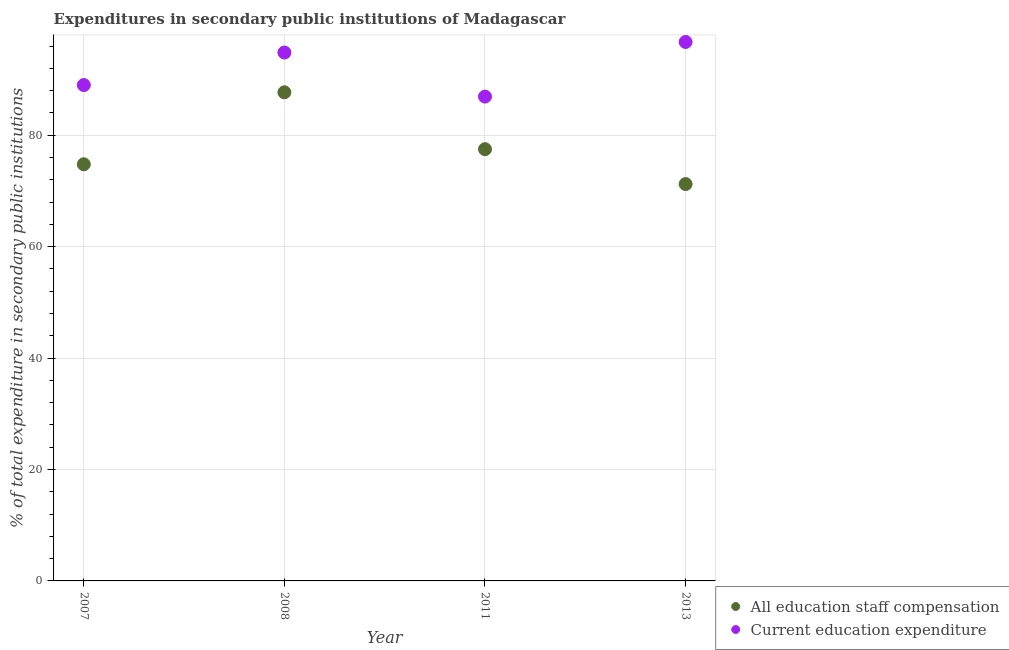How many different coloured dotlines are there?
Your answer should be very brief. 2. What is the expenditure in staff compensation in 2013?
Ensure brevity in your answer.  71.24. Across all years, what is the maximum expenditure in staff compensation?
Your response must be concise. 87.71. Across all years, what is the minimum expenditure in staff compensation?
Your response must be concise. 71.24. What is the total expenditure in staff compensation in the graph?
Offer a very short reply. 311.25. What is the difference between the expenditure in education in 2008 and that in 2013?
Your answer should be compact. -1.89. What is the difference between the expenditure in staff compensation in 2011 and the expenditure in education in 2007?
Your response must be concise. -11.51. What is the average expenditure in staff compensation per year?
Give a very brief answer. 77.81. In the year 2007, what is the difference between the expenditure in education and expenditure in staff compensation?
Your answer should be very brief. 14.22. In how many years, is the expenditure in staff compensation greater than 84 %?
Offer a very short reply. 1. What is the ratio of the expenditure in staff compensation in 2008 to that in 2011?
Offer a very short reply. 1.13. What is the difference between the highest and the second highest expenditure in education?
Your response must be concise. 1.89. What is the difference between the highest and the lowest expenditure in education?
Give a very brief answer. 9.8. Is the sum of the expenditure in education in 2011 and 2013 greater than the maximum expenditure in staff compensation across all years?
Your response must be concise. Yes. Is the expenditure in staff compensation strictly less than the expenditure in education over the years?
Your response must be concise. Yes. How many dotlines are there?
Your response must be concise. 2. Are the values on the major ticks of Y-axis written in scientific E-notation?
Make the answer very short. No. Where does the legend appear in the graph?
Your answer should be very brief. Bottom right. How many legend labels are there?
Your answer should be very brief. 2. What is the title of the graph?
Provide a short and direct response. Expenditures in secondary public institutions of Madagascar. What is the label or title of the X-axis?
Offer a terse response. Year. What is the label or title of the Y-axis?
Your answer should be very brief. % of total expenditure in secondary public institutions. What is the % of total expenditure in secondary public institutions in All education staff compensation in 2007?
Provide a short and direct response. 74.79. What is the % of total expenditure in secondary public institutions in Current education expenditure in 2007?
Provide a succinct answer. 89.01. What is the % of total expenditure in secondary public institutions in All education staff compensation in 2008?
Provide a short and direct response. 87.71. What is the % of total expenditure in secondary public institutions in Current education expenditure in 2008?
Your response must be concise. 94.86. What is the % of total expenditure in secondary public institutions of All education staff compensation in 2011?
Keep it short and to the point. 77.5. What is the % of total expenditure in secondary public institutions of Current education expenditure in 2011?
Make the answer very short. 86.95. What is the % of total expenditure in secondary public institutions in All education staff compensation in 2013?
Your response must be concise. 71.24. What is the % of total expenditure in secondary public institutions of Current education expenditure in 2013?
Give a very brief answer. 96.75. Across all years, what is the maximum % of total expenditure in secondary public institutions of All education staff compensation?
Ensure brevity in your answer.  87.71. Across all years, what is the maximum % of total expenditure in secondary public institutions in Current education expenditure?
Offer a terse response. 96.75. Across all years, what is the minimum % of total expenditure in secondary public institutions of All education staff compensation?
Make the answer very short. 71.24. Across all years, what is the minimum % of total expenditure in secondary public institutions of Current education expenditure?
Give a very brief answer. 86.95. What is the total % of total expenditure in secondary public institutions of All education staff compensation in the graph?
Your answer should be compact. 311.25. What is the total % of total expenditure in secondary public institutions in Current education expenditure in the graph?
Provide a short and direct response. 367.56. What is the difference between the % of total expenditure in secondary public institutions of All education staff compensation in 2007 and that in 2008?
Your answer should be compact. -12.92. What is the difference between the % of total expenditure in secondary public institutions of Current education expenditure in 2007 and that in 2008?
Provide a succinct answer. -5.84. What is the difference between the % of total expenditure in secondary public institutions of All education staff compensation in 2007 and that in 2011?
Your response must be concise. -2.71. What is the difference between the % of total expenditure in secondary public institutions of Current education expenditure in 2007 and that in 2011?
Make the answer very short. 2.07. What is the difference between the % of total expenditure in secondary public institutions of All education staff compensation in 2007 and that in 2013?
Give a very brief answer. 3.55. What is the difference between the % of total expenditure in secondary public institutions of Current education expenditure in 2007 and that in 2013?
Offer a terse response. -7.73. What is the difference between the % of total expenditure in secondary public institutions in All education staff compensation in 2008 and that in 2011?
Your response must be concise. 10.21. What is the difference between the % of total expenditure in secondary public institutions in Current education expenditure in 2008 and that in 2011?
Keep it short and to the point. 7.91. What is the difference between the % of total expenditure in secondary public institutions of All education staff compensation in 2008 and that in 2013?
Your answer should be very brief. 16.47. What is the difference between the % of total expenditure in secondary public institutions in Current education expenditure in 2008 and that in 2013?
Offer a very short reply. -1.89. What is the difference between the % of total expenditure in secondary public institutions of All education staff compensation in 2011 and that in 2013?
Your answer should be compact. 6.26. What is the difference between the % of total expenditure in secondary public institutions of Current education expenditure in 2011 and that in 2013?
Your answer should be compact. -9.8. What is the difference between the % of total expenditure in secondary public institutions in All education staff compensation in 2007 and the % of total expenditure in secondary public institutions in Current education expenditure in 2008?
Ensure brevity in your answer.  -20.06. What is the difference between the % of total expenditure in secondary public institutions in All education staff compensation in 2007 and the % of total expenditure in secondary public institutions in Current education expenditure in 2011?
Offer a very short reply. -12.15. What is the difference between the % of total expenditure in secondary public institutions of All education staff compensation in 2007 and the % of total expenditure in secondary public institutions of Current education expenditure in 2013?
Ensure brevity in your answer.  -21.96. What is the difference between the % of total expenditure in secondary public institutions in All education staff compensation in 2008 and the % of total expenditure in secondary public institutions in Current education expenditure in 2011?
Offer a very short reply. 0.77. What is the difference between the % of total expenditure in secondary public institutions in All education staff compensation in 2008 and the % of total expenditure in secondary public institutions in Current education expenditure in 2013?
Keep it short and to the point. -9.03. What is the difference between the % of total expenditure in secondary public institutions of All education staff compensation in 2011 and the % of total expenditure in secondary public institutions of Current education expenditure in 2013?
Your response must be concise. -19.25. What is the average % of total expenditure in secondary public institutions of All education staff compensation per year?
Give a very brief answer. 77.81. What is the average % of total expenditure in secondary public institutions in Current education expenditure per year?
Provide a succinct answer. 91.89. In the year 2007, what is the difference between the % of total expenditure in secondary public institutions of All education staff compensation and % of total expenditure in secondary public institutions of Current education expenditure?
Provide a succinct answer. -14.22. In the year 2008, what is the difference between the % of total expenditure in secondary public institutions of All education staff compensation and % of total expenditure in secondary public institutions of Current education expenditure?
Your response must be concise. -7.14. In the year 2011, what is the difference between the % of total expenditure in secondary public institutions in All education staff compensation and % of total expenditure in secondary public institutions in Current education expenditure?
Your answer should be very brief. -9.44. In the year 2013, what is the difference between the % of total expenditure in secondary public institutions of All education staff compensation and % of total expenditure in secondary public institutions of Current education expenditure?
Provide a succinct answer. -25.51. What is the ratio of the % of total expenditure in secondary public institutions of All education staff compensation in 2007 to that in 2008?
Your answer should be compact. 0.85. What is the ratio of the % of total expenditure in secondary public institutions of Current education expenditure in 2007 to that in 2008?
Offer a very short reply. 0.94. What is the ratio of the % of total expenditure in secondary public institutions in Current education expenditure in 2007 to that in 2011?
Your answer should be compact. 1.02. What is the ratio of the % of total expenditure in secondary public institutions in All education staff compensation in 2007 to that in 2013?
Keep it short and to the point. 1.05. What is the ratio of the % of total expenditure in secondary public institutions of Current education expenditure in 2007 to that in 2013?
Give a very brief answer. 0.92. What is the ratio of the % of total expenditure in secondary public institutions of All education staff compensation in 2008 to that in 2011?
Provide a succinct answer. 1.13. What is the ratio of the % of total expenditure in secondary public institutions in Current education expenditure in 2008 to that in 2011?
Offer a very short reply. 1.09. What is the ratio of the % of total expenditure in secondary public institutions of All education staff compensation in 2008 to that in 2013?
Make the answer very short. 1.23. What is the ratio of the % of total expenditure in secondary public institutions of Current education expenditure in 2008 to that in 2013?
Give a very brief answer. 0.98. What is the ratio of the % of total expenditure in secondary public institutions in All education staff compensation in 2011 to that in 2013?
Your response must be concise. 1.09. What is the ratio of the % of total expenditure in secondary public institutions in Current education expenditure in 2011 to that in 2013?
Offer a very short reply. 0.9. What is the difference between the highest and the second highest % of total expenditure in secondary public institutions in All education staff compensation?
Provide a succinct answer. 10.21. What is the difference between the highest and the second highest % of total expenditure in secondary public institutions in Current education expenditure?
Offer a terse response. 1.89. What is the difference between the highest and the lowest % of total expenditure in secondary public institutions of All education staff compensation?
Provide a short and direct response. 16.47. What is the difference between the highest and the lowest % of total expenditure in secondary public institutions in Current education expenditure?
Your answer should be compact. 9.8. 